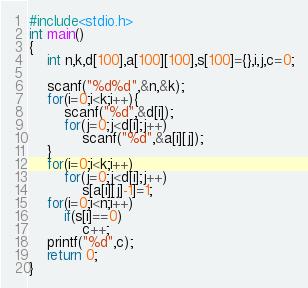<code> <loc_0><loc_0><loc_500><loc_500><_C_>#include<stdio.h>
int main()
{
	int n,k,d[100],a[100][100],s[100]={},i,j,c=0;

	scanf("%d%d",&n,&k);
	for(i=0;i<k;i++){
		scanf("%d",&d[i]);
		for(j=0;j<d[i];j++)
			scanf("%d",&a[i][j]);
	}
	for(i=0;i<k;i++)
		for(j=0;j<d[i];j++)
			s[a[i][j]-1]=1;
	for(i=0;i<n;i++)
		if(s[i]==0)
			c++;
	printf("%d",c);
	return 0;
}</code> 